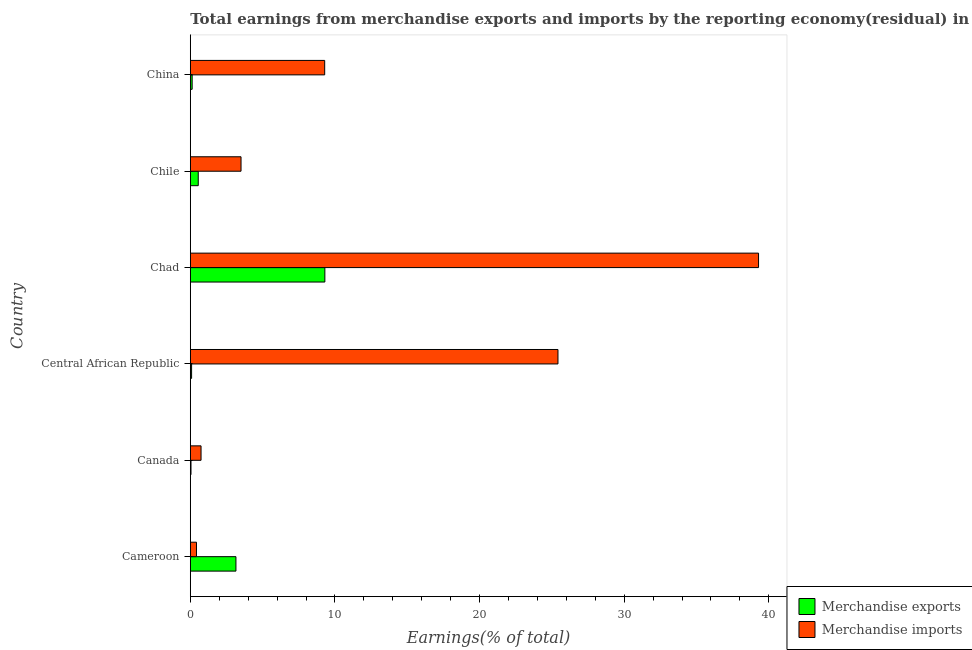How many different coloured bars are there?
Your answer should be compact. 2. How many groups of bars are there?
Your answer should be compact. 6. Are the number of bars per tick equal to the number of legend labels?
Ensure brevity in your answer.  Yes. Are the number of bars on each tick of the Y-axis equal?
Your answer should be compact. Yes. What is the label of the 6th group of bars from the top?
Keep it short and to the point. Cameroon. What is the earnings from merchandise imports in Chile?
Keep it short and to the point. 3.51. Across all countries, what is the maximum earnings from merchandise imports?
Provide a succinct answer. 39.29. Across all countries, what is the minimum earnings from merchandise exports?
Offer a very short reply. 0.05. In which country was the earnings from merchandise exports maximum?
Provide a succinct answer. Chad. In which country was the earnings from merchandise exports minimum?
Make the answer very short. Canada. What is the total earnings from merchandise imports in the graph?
Ensure brevity in your answer.  78.68. What is the difference between the earnings from merchandise exports in Chad and that in China?
Offer a very short reply. 9.18. What is the difference between the earnings from merchandise imports in Cameroon and the earnings from merchandise exports in China?
Keep it short and to the point. 0.3. What is the average earnings from merchandise imports per country?
Ensure brevity in your answer.  13.11. What is the difference between the earnings from merchandise imports and earnings from merchandise exports in Chile?
Provide a succinct answer. 2.96. What is the ratio of the earnings from merchandise exports in Chad to that in Chile?
Your answer should be compact. 16.91. What is the difference between the highest and the second highest earnings from merchandise imports?
Offer a terse response. 13.87. What is the difference between the highest and the lowest earnings from merchandise exports?
Your answer should be compact. 9.26. Is the sum of the earnings from merchandise exports in Chad and Chile greater than the maximum earnings from merchandise imports across all countries?
Keep it short and to the point. No. What does the 2nd bar from the top in Chad represents?
Offer a terse response. Merchandise exports. How many countries are there in the graph?
Your answer should be compact. 6. Are the values on the major ticks of X-axis written in scientific E-notation?
Make the answer very short. No. Does the graph contain any zero values?
Provide a succinct answer. No. How many legend labels are there?
Your answer should be compact. 2. What is the title of the graph?
Provide a succinct answer. Total earnings from merchandise exports and imports by the reporting economy(residual) in 2013. What is the label or title of the X-axis?
Offer a terse response. Earnings(% of total). What is the Earnings(% of total) in Merchandise exports in Cameroon?
Your answer should be compact. 3.16. What is the Earnings(% of total) of Merchandise imports in Cameroon?
Keep it short and to the point. 0.43. What is the Earnings(% of total) in Merchandise exports in Canada?
Offer a terse response. 0.05. What is the Earnings(% of total) in Merchandise imports in Canada?
Ensure brevity in your answer.  0.74. What is the Earnings(% of total) of Merchandise exports in Central African Republic?
Give a very brief answer. 0.09. What is the Earnings(% of total) of Merchandise imports in Central African Republic?
Offer a terse response. 25.42. What is the Earnings(% of total) of Merchandise exports in Chad?
Your answer should be compact. 9.3. What is the Earnings(% of total) in Merchandise imports in Chad?
Offer a very short reply. 39.29. What is the Earnings(% of total) of Merchandise exports in Chile?
Make the answer very short. 0.55. What is the Earnings(% of total) of Merchandise imports in Chile?
Your answer should be compact. 3.51. What is the Earnings(% of total) in Merchandise exports in China?
Make the answer very short. 0.13. What is the Earnings(% of total) in Merchandise imports in China?
Your answer should be very brief. 9.29. Across all countries, what is the maximum Earnings(% of total) of Merchandise exports?
Your answer should be compact. 9.3. Across all countries, what is the maximum Earnings(% of total) in Merchandise imports?
Your answer should be compact. 39.29. Across all countries, what is the minimum Earnings(% of total) in Merchandise exports?
Ensure brevity in your answer.  0.05. Across all countries, what is the minimum Earnings(% of total) in Merchandise imports?
Provide a succinct answer. 0.43. What is the total Earnings(% of total) in Merchandise exports in the graph?
Make the answer very short. 13.28. What is the total Earnings(% of total) in Merchandise imports in the graph?
Offer a very short reply. 78.68. What is the difference between the Earnings(% of total) of Merchandise exports in Cameroon and that in Canada?
Offer a terse response. 3.11. What is the difference between the Earnings(% of total) of Merchandise imports in Cameroon and that in Canada?
Offer a very short reply. -0.32. What is the difference between the Earnings(% of total) of Merchandise exports in Cameroon and that in Central African Republic?
Ensure brevity in your answer.  3.07. What is the difference between the Earnings(% of total) of Merchandise imports in Cameroon and that in Central African Republic?
Your answer should be very brief. -24.99. What is the difference between the Earnings(% of total) of Merchandise exports in Cameroon and that in Chad?
Keep it short and to the point. -6.15. What is the difference between the Earnings(% of total) of Merchandise imports in Cameroon and that in Chad?
Provide a short and direct response. -38.86. What is the difference between the Earnings(% of total) in Merchandise exports in Cameroon and that in Chile?
Provide a succinct answer. 2.61. What is the difference between the Earnings(% of total) of Merchandise imports in Cameroon and that in Chile?
Give a very brief answer. -3.08. What is the difference between the Earnings(% of total) of Merchandise exports in Cameroon and that in China?
Ensure brevity in your answer.  3.03. What is the difference between the Earnings(% of total) of Merchandise imports in Cameroon and that in China?
Your answer should be very brief. -8.86. What is the difference between the Earnings(% of total) in Merchandise exports in Canada and that in Central African Republic?
Your response must be concise. -0.04. What is the difference between the Earnings(% of total) in Merchandise imports in Canada and that in Central African Republic?
Provide a short and direct response. -24.68. What is the difference between the Earnings(% of total) in Merchandise exports in Canada and that in Chad?
Your answer should be compact. -9.26. What is the difference between the Earnings(% of total) of Merchandise imports in Canada and that in Chad?
Your answer should be compact. -38.55. What is the difference between the Earnings(% of total) in Merchandise exports in Canada and that in Chile?
Your response must be concise. -0.5. What is the difference between the Earnings(% of total) of Merchandise imports in Canada and that in Chile?
Offer a very short reply. -2.76. What is the difference between the Earnings(% of total) in Merchandise exports in Canada and that in China?
Your answer should be very brief. -0.08. What is the difference between the Earnings(% of total) in Merchandise imports in Canada and that in China?
Ensure brevity in your answer.  -8.55. What is the difference between the Earnings(% of total) of Merchandise exports in Central African Republic and that in Chad?
Provide a short and direct response. -9.21. What is the difference between the Earnings(% of total) of Merchandise imports in Central African Republic and that in Chad?
Your answer should be very brief. -13.87. What is the difference between the Earnings(% of total) in Merchandise exports in Central African Republic and that in Chile?
Provide a short and direct response. -0.46. What is the difference between the Earnings(% of total) in Merchandise imports in Central African Republic and that in Chile?
Make the answer very short. 21.91. What is the difference between the Earnings(% of total) in Merchandise exports in Central African Republic and that in China?
Offer a very short reply. -0.04. What is the difference between the Earnings(% of total) in Merchandise imports in Central African Republic and that in China?
Provide a succinct answer. 16.13. What is the difference between the Earnings(% of total) in Merchandise exports in Chad and that in Chile?
Offer a very short reply. 8.75. What is the difference between the Earnings(% of total) in Merchandise imports in Chad and that in Chile?
Ensure brevity in your answer.  35.78. What is the difference between the Earnings(% of total) in Merchandise exports in Chad and that in China?
Give a very brief answer. 9.18. What is the difference between the Earnings(% of total) in Merchandise imports in Chad and that in China?
Make the answer very short. 30. What is the difference between the Earnings(% of total) of Merchandise exports in Chile and that in China?
Keep it short and to the point. 0.42. What is the difference between the Earnings(% of total) of Merchandise imports in Chile and that in China?
Ensure brevity in your answer.  -5.78. What is the difference between the Earnings(% of total) in Merchandise exports in Cameroon and the Earnings(% of total) in Merchandise imports in Canada?
Offer a terse response. 2.41. What is the difference between the Earnings(% of total) of Merchandise exports in Cameroon and the Earnings(% of total) of Merchandise imports in Central African Republic?
Keep it short and to the point. -22.27. What is the difference between the Earnings(% of total) in Merchandise exports in Cameroon and the Earnings(% of total) in Merchandise imports in Chad?
Provide a succinct answer. -36.13. What is the difference between the Earnings(% of total) of Merchandise exports in Cameroon and the Earnings(% of total) of Merchandise imports in Chile?
Offer a very short reply. -0.35. What is the difference between the Earnings(% of total) in Merchandise exports in Cameroon and the Earnings(% of total) in Merchandise imports in China?
Provide a short and direct response. -6.14. What is the difference between the Earnings(% of total) in Merchandise exports in Canada and the Earnings(% of total) in Merchandise imports in Central African Republic?
Provide a short and direct response. -25.37. What is the difference between the Earnings(% of total) of Merchandise exports in Canada and the Earnings(% of total) of Merchandise imports in Chad?
Your answer should be very brief. -39.24. What is the difference between the Earnings(% of total) of Merchandise exports in Canada and the Earnings(% of total) of Merchandise imports in Chile?
Provide a succinct answer. -3.46. What is the difference between the Earnings(% of total) in Merchandise exports in Canada and the Earnings(% of total) in Merchandise imports in China?
Make the answer very short. -9.24. What is the difference between the Earnings(% of total) in Merchandise exports in Central African Republic and the Earnings(% of total) in Merchandise imports in Chad?
Give a very brief answer. -39.2. What is the difference between the Earnings(% of total) in Merchandise exports in Central African Republic and the Earnings(% of total) in Merchandise imports in Chile?
Offer a very short reply. -3.42. What is the difference between the Earnings(% of total) in Merchandise exports in Central African Republic and the Earnings(% of total) in Merchandise imports in China?
Offer a very short reply. -9.2. What is the difference between the Earnings(% of total) of Merchandise exports in Chad and the Earnings(% of total) of Merchandise imports in Chile?
Keep it short and to the point. 5.8. What is the difference between the Earnings(% of total) in Merchandise exports in Chad and the Earnings(% of total) in Merchandise imports in China?
Provide a short and direct response. 0.01. What is the difference between the Earnings(% of total) of Merchandise exports in Chile and the Earnings(% of total) of Merchandise imports in China?
Provide a short and direct response. -8.74. What is the average Earnings(% of total) of Merchandise exports per country?
Offer a terse response. 2.21. What is the average Earnings(% of total) in Merchandise imports per country?
Give a very brief answer. 13.11. What is the difference between the Earnings(% of total) of Merchandise exports and Earnings(% of total) of Merchandise imports in Cameroon?
Your answer should be compact. 2.73. What is the difference between the Earnings(% of total) of Merchandise exports and Earnings(% of total) of Merchandise imports in Canada?
Offer a terse response. -0.69. What is the difference between the Earnings(% of total) of Merchandise exports and Earnings(% of total) of Merchandise imports in Central African Republic?
Provide a short and direct response. -25.33. What is the difference between the Earnings(% of total) in Merchandise exports and Earnings(% of total) in Merchandise imports in Chad?
Offer a very short reply. -29.99. What is the difference between the Earnings(% of total) of Merchandise exports and Earnings(% of total) of Merchandise imports in Chile?
Make the answer very short. -2.96. What is the difference between the Earnings(% of total) of Merchandise exports and Earnings(% of total) of Merchandise imports in China?
Provide a short and direct response. -9.16. What is the ratio of the Earnings(% of total) in Merchandise exports in Cameroon to that in Canada?
Provide a short and direct response. 65.32. What is the ratio of the Earnings(% of total) of Merchandise imports in Cameroon to that in Canada?
Ensure brevity in your answer.  0.58. What is the ratio of the Earnings(% of total) in Merchandise exports in Cameroon to that in Central African Republic?
Provide a short and direct response. 35.14. What is the ratio of the Earnings(% of total) in Merchandise imports in Cameroon to that in Central African Republic?
Ensure brevity in your answer.  0.02. What is the ratio of the Earnings(% of total) in Merchandise exports in Cameroon to that in Chad?
Provide a short and direct response. 0.34. What is the ratio of the Earnings(% of total) of Merchandise imports in Cameroon to that in Chad?
Offer a terse response. 0.01. What is the ratio of the Earnings(% of total) in Merchandise exports in Cameroon to that in Chile?
Your response must be concise. 5.74. What is the ratio of the Earnings(% of total) of Merchandise imports in Cameroon to that in Chile?
Your answer should be very brief. 0.12. What is the ratio of the Earnings(% of total) of Merchandise exports in Cameroon to that in China?
Give a very brief answer. 24.6. What is the ratio of the Earnings(% of total) in Merchandise imports in Cameroon to that in China?
Keep it short and to the point. 0.05. What is the ratio of the Earnings(% of total) in Merchandise exports in Canada to that in Central African Republic?
Your response must be concise. 0.54. What is the ratio of the Earnings(% of total) of Merchandise imports in Canada to that in Central African Republic?
Offer a very short reply. 0.03. What is the ratio of the Earnings(% of total) of Merchandise exports in Canada to that in Chad?
Provide a short and direct response. 0.01. What is the ratio of the Earnings(% of total) in Merchandise imports in Canada to that in Chad?
Ensure brevity in your answer.  0.02. What is the ratio of the Earnings(% of total) in Merchandise exports in Canada to that in Chile?
Make the answer very short. 0.09. What is the ratio of the Earnings(% of total) of Merchandise imports in Canada to that in Chile?
Provide a succinct answer. 0.21. What is the ratio of the Earnings(% of total) of Merchandise exports in Canada to that in China?
Ensure brevity in your answer.  0.38. What is the ratio of the Earnings(% of total) in Merchandise imports in Canada to that in China?
Ensure brevity in your answer.  0.08. What is the ratio of the Earnings(% of total) in Merchandise exports in Central African Republic to that in Chad?
Your answer should be compact. 0.01. What is the ratio of the Earnings(% of total) in Merchandise imports in Central African Republic to that in Chad?
Make the answer very short. 0.65. What is the ratio of the Earnings(% of total) of Merchandise exports in Central African Republic to that in Chile?
Make the answer very short. 0.16. What is the ratio of the Earnings(% of total) of Merchandise imports in Central African Republic to that in Chile?
Make the answer very short. 7.25. What is the ratio of the Earnings(% of total) in Merchandise imports in Central African Republic to that in China?
Make the answer very short. 2.74. What is the ratio of the Earnings(% of total) in Merchandise exports in Chad to that in Chile?
Ensure brevity in your answer.  16.91. What is the ratio of the Earnings(% of total) of Merchandise imports in Chad to that in Chile?
Offer a very short reply. 11.2. What is the ratio of the Earnings(% of total) of Merchandise exports in Chad to that in China?
Provide a succinct answer. 72.51. What is the ratio of the Earnings(% of total) in Merchandise imports in Chad to that in China?
Make the answer very short. 4.23. What is the ratio of the Earnings(% of total) in Merchandise exports in Chile to that in China?
Offer a very short reply. 4.29. What is the ratio of the Earnings(% of total) in Merchandise imports in Chile to that in China?
Provide a succinct answer. 0.38. What is the difference between the highest and the second highest Earnings(% of total) of Merchandise exports?
Keep it short and to the point. 6.15. What is the difference between the highest and the second highest Earnings(% of total) of Merchandise imports?
Ensure brevity in your answer.  13.87. What is the difference between the highest and the lowest Earnings(% of total) of Merchandise exports?
Offer a terse response. 9.26. What is the difference between the highest and the lowest Earnings(% of total) of Merchandise imports?
Offer a terse response. 38.86. 